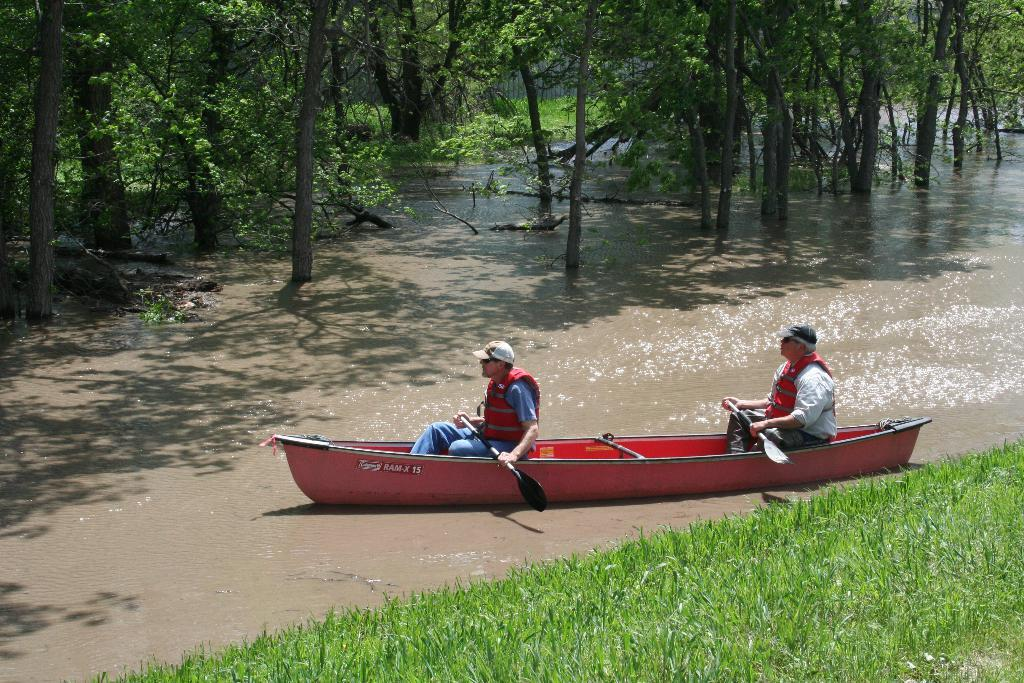What color is the boat in the image? The boat in the image is red. How many people are in the boat? Two people are sitting in the boat. What are the people using to move the boat? There are paddles visible in the image. What can be seen behind the boat? There are trees visible behind the boat. What type of environment is the boat in? There is water visible in the image, and green grass is visible in front of the boat. What type of example can be seen in the image? There is no example present in the image; it features a red boat with two people and paddles in a water environment with trees and green grass. How many crows are visible in the image? There are no crows present in the image. 